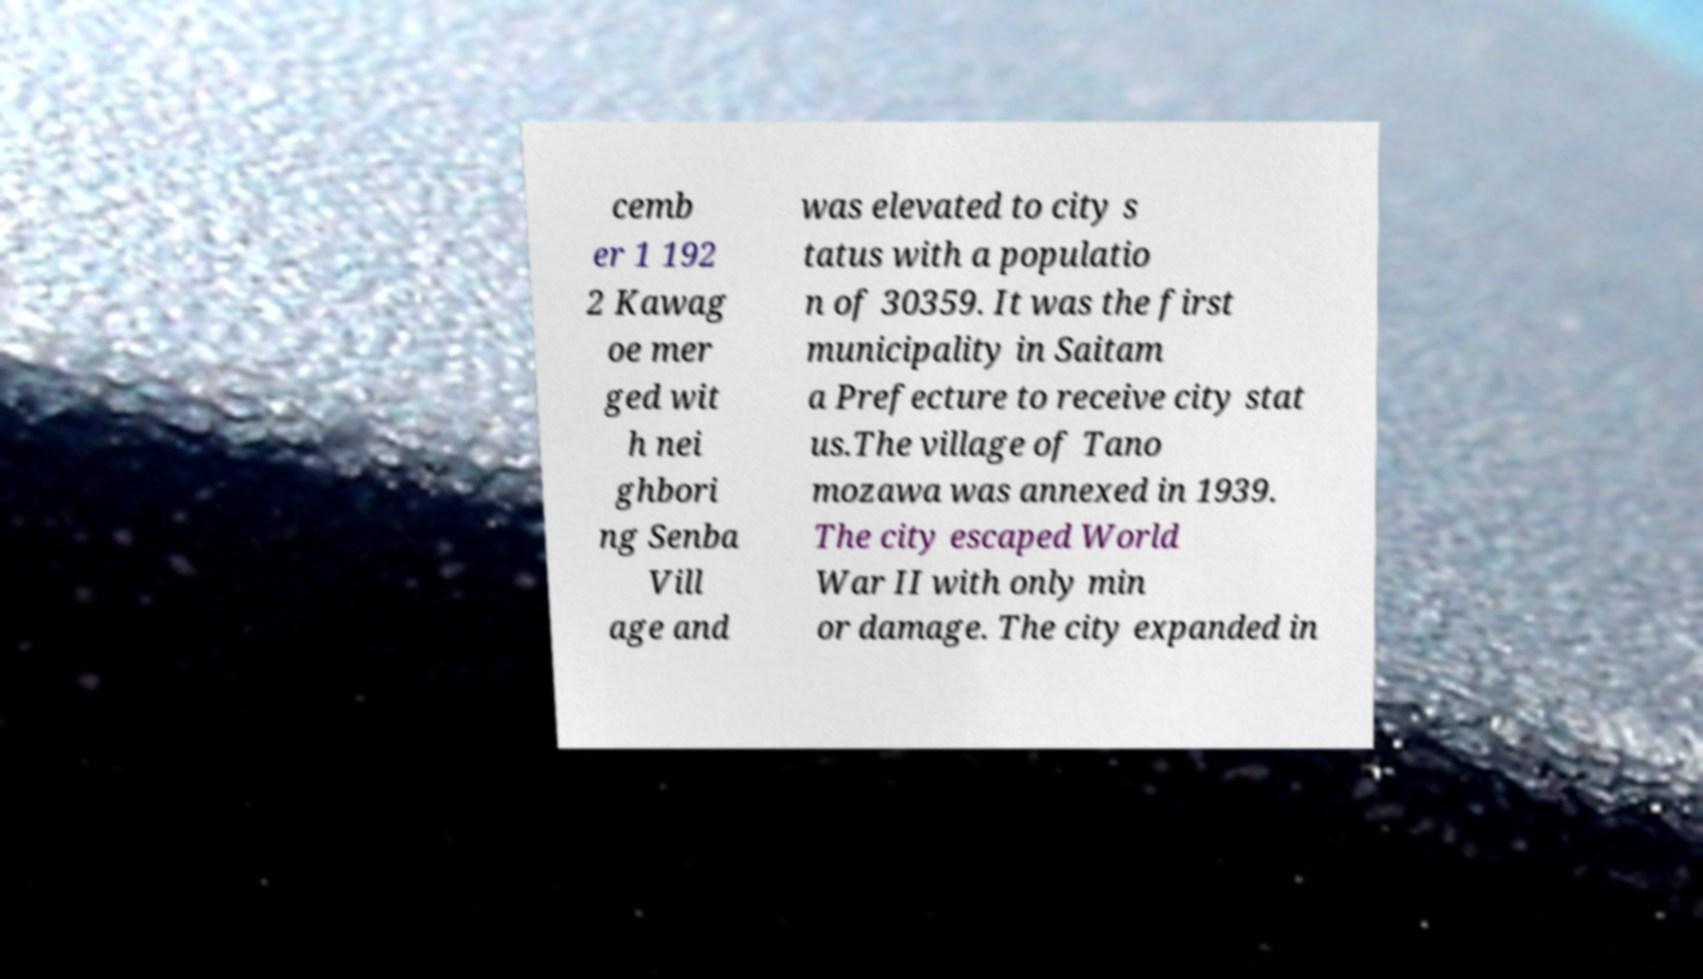Could you extract and type out the text from this image? cemb er 1 192 2 Kawag oe mer ged wit h nei ghbori ng Senba Vill age and was elevated to city s tatus with a populatio n of 30359. It was the first municipality in Saitam a Prefecture to receive city stat us.The village of Tano mozawa was annexed in 1939. The city escaped World War II with only min or damage. The city expanded in 